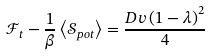<formula> <loc_0><loc_0><loc_500><loc_500>\mathcal { F } _ { t } - \frac { 1 } { \beta } \left \langle \mathcal { S } _ { p o t } \right \rangle = \frac { D v \left ( 1 - \lambda \right ) ^ { 2 } } { 4 }</formula> 